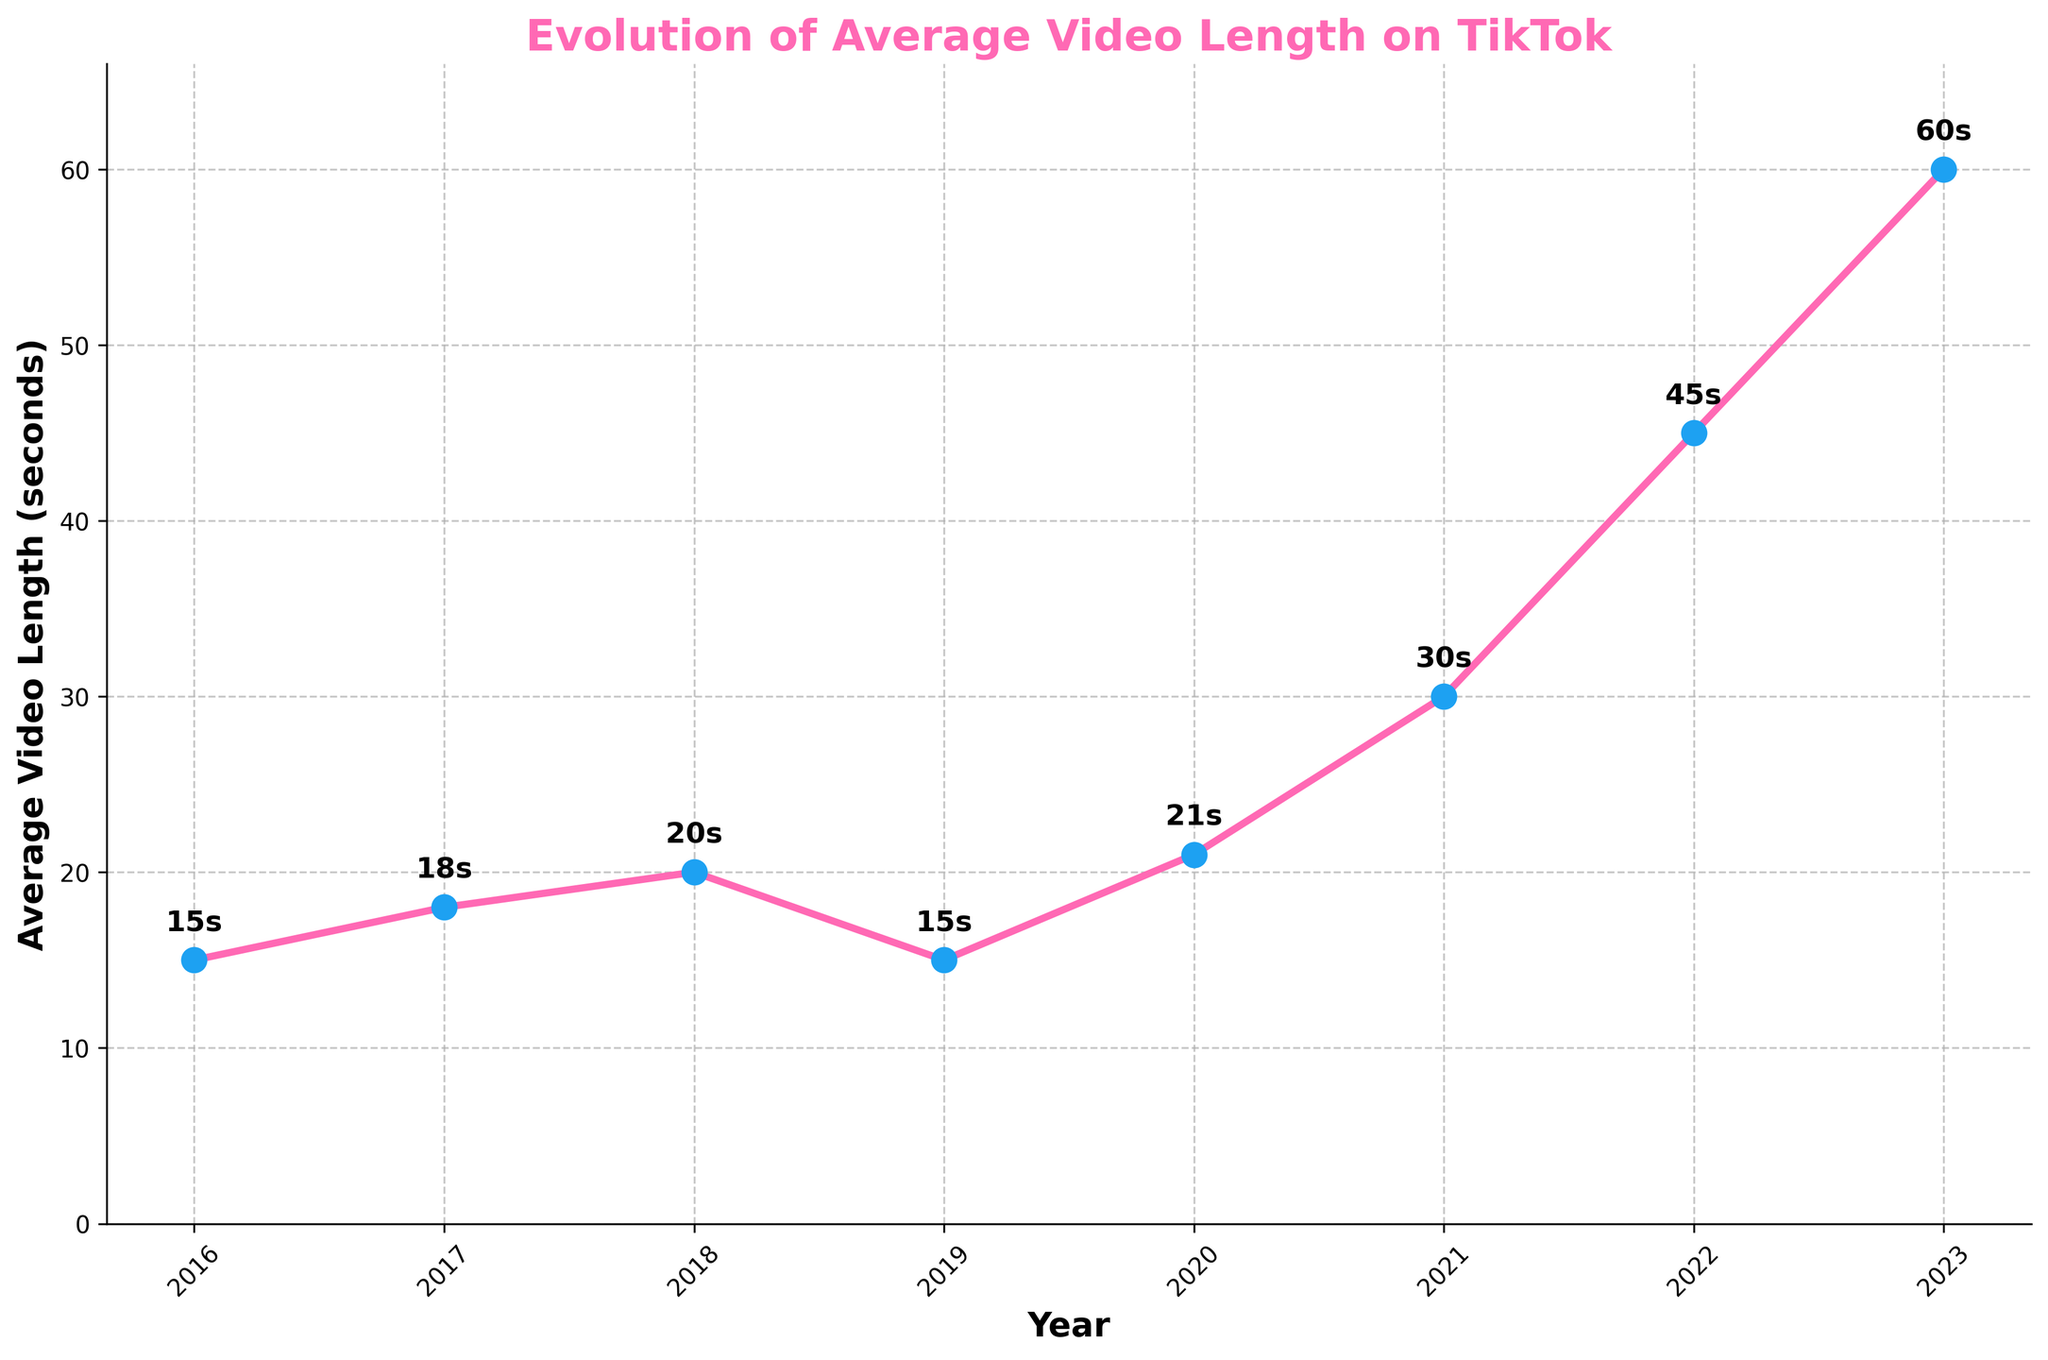What's the average video length for the years 2016 and 2019? Add the video lengths for 2016 and 2019, which are 15 seconds each, then divide by 2 to get the average. (15 + 15) / 2 = 15
Answer: 15 Which year had the longest average video length? Look at the year with the highest value on the y-axis. The longest average video length is 60 seconds in 2023.
Answer: 2023 What is the difference in average video length between 2022 and 2023? Subtract the average video length in 2022 from that in 2023. 60 - 45 = 15
Answer: 15 By how many seconds did the average video length increase from 2021 to 2022? Subtract the average video length in 2021 from that in 2022. 45 - 30 = 15
Answer: 15 Which period experienced the sharpest increase in average video length? Identify the period with the steepest slope. From 2021 to 2023, the average video length increased from 30 seconds to 60 seconds.
Answer: 2021-2023 Which years experienced a decrease in average video length? Find the years where the average video length declined compared to the previous year. From 2018 to 2019, the length decreased from 20 to 15 seconds.
Answer: 2019 What's the cumulative increase in average video length from 2016 to 2023? Subtract the video length of 2016 from that of 2023 to find the total increase. 60 - 15 = 45
Answer: 45 Which year shows a return to the previous average video length measured in an earlier year? The average video length in 2019 (15 seconds) returned to the same value as in 2016.
Answer: 2019 In which time period did the average video length remain constant? Identify the time span where the average video length did not change. From 2016 to 2017, there was no constant period.
Answer: None 